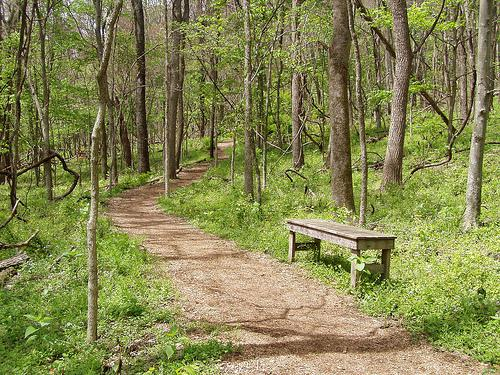Question: what is cast?
Choices:
A. Reflection.
B. A spell.
C. A die.
D. Shadow.
Answer with the letter. Answer: D 